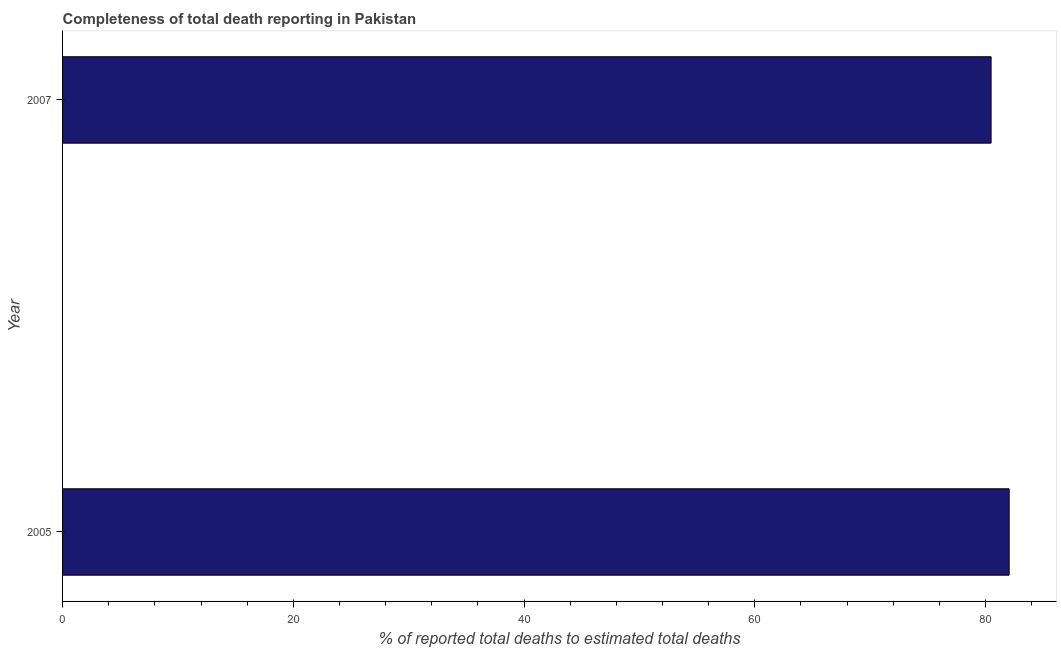What is the title of the graph?
Give a very brief answer. Completeness of total death reporting in Pakistan. What is the label or title of the X-axis?
Your answer should be very brief. % of reported total deaths to estimated total deaths. What is the label or title of the Y-axis?
Keep it short and to the point. Year. What is the completeness of total death reports in 2007?
Give a very brief answer. 80.48. Across all years, what is the maximum completeness of total death reports?
Make the answer very short. 82.05. Across all years, what is the minimum completeness of total death reports?
Offer a very short reply. 80.48. In which year was the completeness of total death reports maximum?
Keep it short and to the point. 2005. What is the sum of the completeness of total death reports?
Provide a succinct answer. 162.53. What is the difference between the completeness of total death reports in 2005 and 2007?
Make the answer very short. 1.57. What is the average completeness of total death reports per year?
Make the answer very short. 81.27. What is the median completeness of total death reports?
Make the answer very short. 81.27. Do a majority of the years between 2007 and 2005 (inclusive) have completeness of total death reports greater than 44 %?
Your response must be concise. No. What is the ratio of the completeness of total death reports in 2005 to that in 2007?
Offer a very short reply. 1.02. Is the completeness of total death reports in 2005 less than that in 2007?
Ensure brevity in your answer.  No. In how many years, is the completeness of total death reports greater than the average completeness of total death reports taken over all years?
Give a very brief answer. 1. How many bars are there?
Provide a succinct answer. 2. Are the values on the major ticks of X-axis written in scientific E-notation?
Give a very brief answer. No. What is the % of reported total deaths to estimated total deaths of 2005?
Give a very brief answer. 82.05. What is the % of reported total deaths to estimated total deaths in 2007?
Your answer should be compact. 80.48. What is the difference between the % of reported total deaths to estimated total deaths in 2005 and 2007?
Give a very brief answer. 1.57. What is the ratio of the % of reported total deaths to estimated total deaths in 2005 to that in 2007?
Your response must be concise. 1.02. 